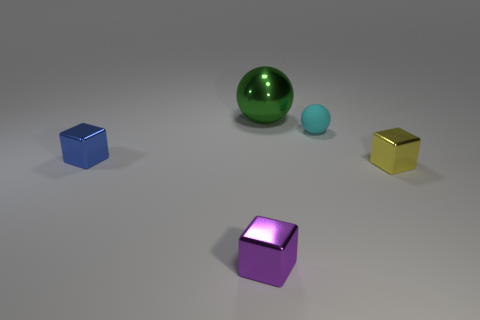Subtract all yellow balls. Subtract all purple cubes. How many balls are left? 2 Add 2 large purple rubber blocks. How many objects exist? 7 Subtract all cubes. How many objects are left? 2 Add 3 yellow metal cubes. How many yellow metal cubes are left? 4 Add 3 tiny yellow cubes. How many tiny yellow cubes exist? 4 Subtract 0 brown balls. How many objects are left? 5 Subtract all tiny blue shiny blocks. Subtract all small shiny blocks. How many objects are left? 1 